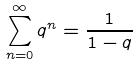Convert formula to latex. <formula><loc_0><loc_0><loc_500><loc_500>\sum _ { n = 0 } ^ { \infty } q ^ { n } = \frac { 1 } { 1 - q }</formula> 